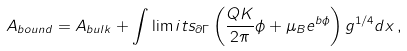Convert formula to latex. <formula><loc_0><loc_0><loc_500><loc_500>A _ { b o u n d } = A _ { b u l k } + \int \lim i t s _ { \partial \Gamma } \left ( \frac { Q K } { 2 \pi } \phi + \mu _ { B } e ^ { b \phi } \right ) g ^ { 1 / 4 } d x \, ,</formula> 